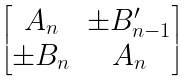<formula> <loc_0><loc_0><loc_500><loc_500>\begin{bmatrix} A _ { n } & \pm B _ { n - 1 } ^ { \prime } \\ \pm B _ { n } & A _ { n } \end{bmatrix}</formula> 